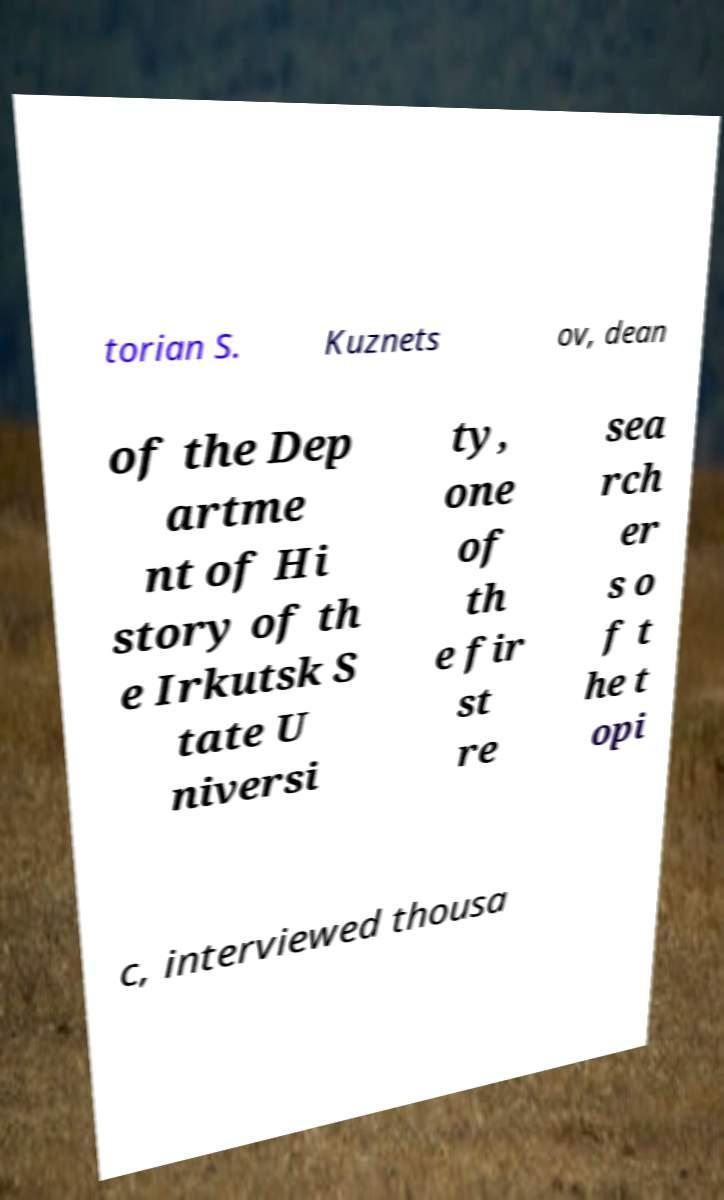What messages or text are displayed in this image? I need them in a readable, typed format. torian S. Kuznets ov, dean of the Dep artme nt of Hi story of th e Irkutsk S tate U niversi ty, one of th e fir st re sea rch er s o f t he t opi c, interviewed thousa 